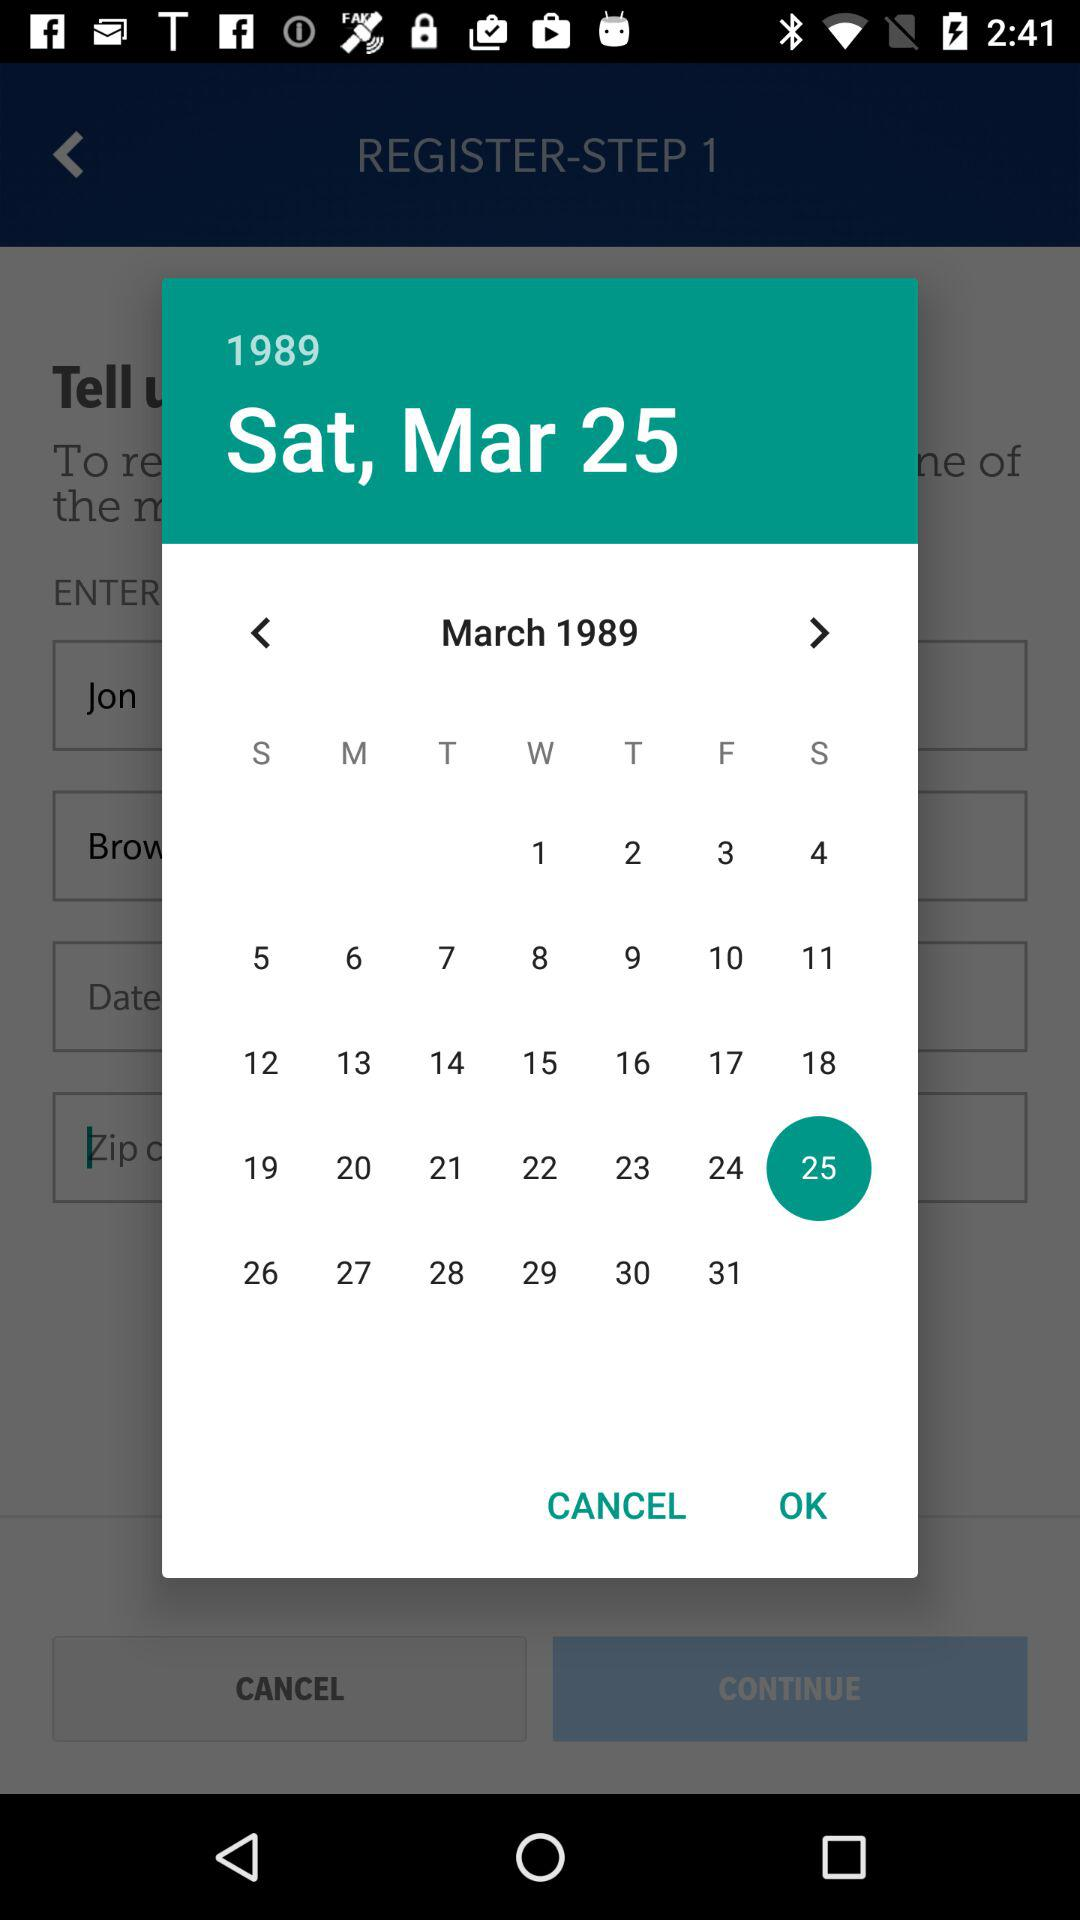What is the date? The date is Saturday, March 25, 1989. 